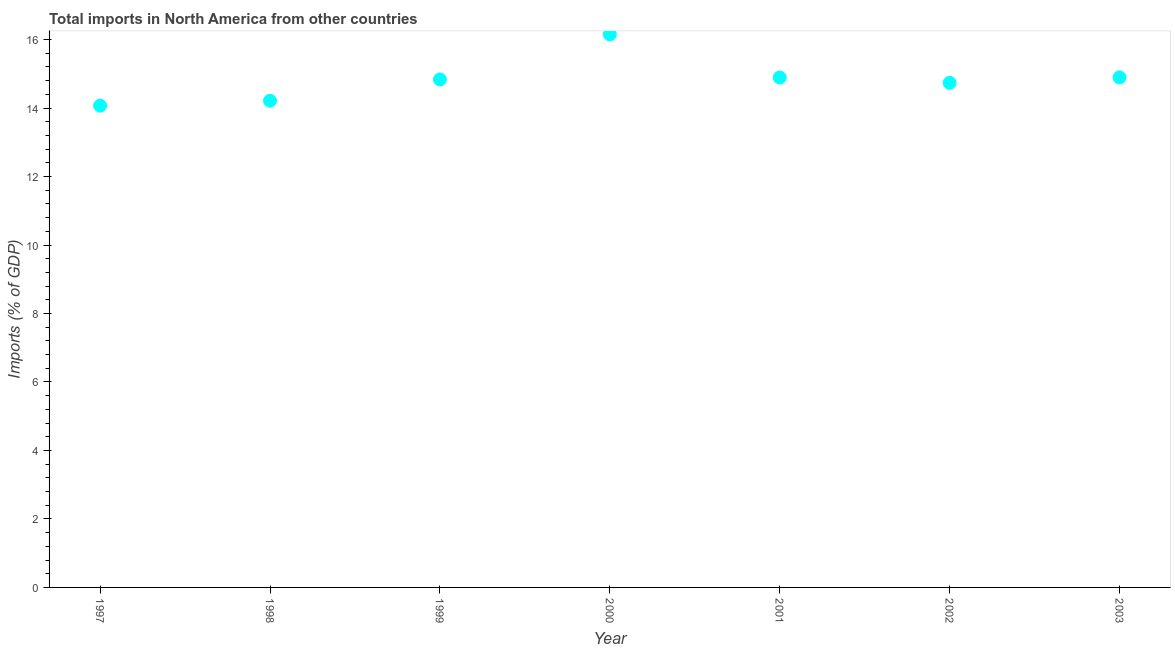What is the total imports in 1997?
Your answer should be very brief. 14.07. Across all years, what is the maximum total imports?
Your answer should be compact. 16.15. Across all years, what is the minimum total imports?
Offer a terse response. 14.07. In which year was the total imports minimum?
Provide a succinct answer. 1997. What is the sum of the total imports?
Offer a terse response. 103.8. What is the difference between the total imports in 2001 and 2003?
Provide a succinct answer. -0. What is the average total imports per year?
Offer a terse response. 14.83. What is the median total imports?
Offer a terse response. 14.84. What is the ratio of the total imports in 1998 to that in 2003?
Your answer should be compact. 0.95. Is the difference between the total imports in 2000 and 2002 greater than the difference between any two years?
Keep it short and to the point. No. What is the difference between the highest and the second highest total imports?
Provide a short and direct response. 1.26. Is the sum of the total imports in 1999 and 2003 greater than the maximum total imports across all years?
Offer a very short reply. Yes. What is the difference between the highest and the lowest total imports?
Give a very brief answer. 2.08. How many dotlines are there?
Offer a very short reply. 1. How many years are there in the graph?
Give a very brief answer. 7. Are the values on the major ticks of Y-axis written in scientific E-notation?
Make the answer very short. No. Does the graph contain any zero values?
Make the answer very short. No. What is the title of the graph?
Provide a succinct answer. Total imports in North America from other countries. What is the label or title of the X-axis?
Give a very brief answer. Year. What is the label or title of the Y-axis?
Ensure brevity in your answer.  Imports (% of GDP). What is the Imports (% of GDP) in 1997?
Your answer should be compact. 14.07. What is the Imports (% of GDP) in 1998?
Make the answer very short. 14.21. What is the Imports (% of GDP) in 1999?
Provide a succinct answer. 14.84. What is the Imports (% of GDP) in 2000?
Your answer should be compact. 16.15. What is the Imports (% of GDP) in 2001?
Your answer should be very brief. 14.89. What is the Imports (% of GDP) in 2002?
Offer a terse response. 14.74. What is the Imports (% of GDP) in 2003?
Offer a very short reply. 14.9. What is the difference between the Imports (% of GDP) in 1997 and 1998?
Provide a short and direct response. -0.14. What is the difference between the Imports (% of GDP) in 1997 and 1999?
Your answer should be very brief. -0.77. What is the difference between the Imports (% of GDP) in 1997 and 2000?
Ensure brevity in your answer.  -2.08. What is the difference between the Imports (% of GDP) in 1997 and 2001?
Make the answer very short. -0.82. What is the difference between the Imports (% of GDP) in 1997 and 2002?
Provide a succinct answer. -0.67. What is the difference between the Imports (% of GDP) in 1997 and 2003?
Keep it short and to the point. -0.83. What is the difference between the Imports (% of GDP) in 1998 and 1999?
Your answer should be very brief. -0.62. What is the difference between the Imports (% of GDP) in 1998 and 2000?
Provide a succinct answer. -1.94. What is the difference between the Imports (% of GDP) in 1998 and 2001?
Your answer should be compact. -0.68. What is the difference between the Imports (% of GDP) in 1998 and 2002?
Give a very brief answer. -0.52. What is the difference between the Imports (% of GDP) in 1998 and 2003?
Make the answer very short. -0.68. What is the difference between the Imports (% of GDP) in 1999 and 2000?
Provide a succinct answer. -1.32. What is the difference between the Imports (% of GDP) in 1999 and 2001?
Offer a very short reply. -0.06. What is the difference between the Imports (% of GDP) in 1999 and 2002?
Keep it short and to the point. 0.1. What is the difference between the Imports (% of GDP) in 1999 and 2003?
Ensure brevity in your answer.  -0.06. What is the difference between the Imports (% of GDP) in 2000 and 2001?
Keep it short and to the point. 1.26. What is the difference between the Imports (% of GDP) in 2000 and 2002?
Make the answer very short. 1.41. What is the difference between the Imports (% of GDP) in 2000 and 2003?
Offer a terse response. 1.26. What is the difference between the Imports (% of GDP) in 2001 and 2002?
Your answer should be compact. 0.16. What is the difference between the Imports (% of GDP) in 2001 and 2003?
Your answer should be compact. -0. What is the difference between the Imports (% of GDP) in 2002 and 2003?
Make the answer very short. -0.16. What is the ratio of the Imports (% of GDP) in 1997 to that in 1998?
Give a very brief answer. 0.99. What is the ratio of the Imports (% of GDP) in 1997 to that in 1999?
Keep it short and to the point. 0.95. What is the ratio of the Imports (% of GDP) in 1997 to that in 2000?
Provide a short and direct response. 0.87. What is the ratio of the Imports (% of GDP) in 1997 to that in 2001?
Offer a very short reply. 0.94. What is the ratio of the Imports (% of GDP) in 1997 to that in 2002?
Keep it short and to the point. 0.95. What is the ratio of the Imports (% of GDP) in 1997 to that in 2003?
Your answer should be compact. 0.94. What is the ratio of the Imports (% of GDP) in 1998 to that in 1999?
Ensure brevity in your answer.  0.96. What is the ratio of the Imports (% of GDP) in 1998 to that in 2000?
Ensure brevity in your answer.  0.88. What is the ratio of the Imports (% of GDP) in 1998 to that in 2001?
Your answer should be compact. 0.95. What is the ratio of the Imports (% of GDP) in 1998 to that in 2002?
Give a very brief answer. 0.96. What is the ratio of the Imports (% of GDP) in 1998 to that in 2003?
Offer a terse response. 0.95. What is the ratio of the Imports (% of GDP) in 1999 to that in 2000?
Make the answer very short. 0.92. What is the ratio of the Imports (% of GDP) in 1999 to that in 2002?
Give a very brief answer. 1.01. What is the ratio of the Imports (% of GDP) in 1999 to that in 2003?
Offer a terse response. 1. What is the ratio of the Imports (% of GDP) in 2000 to that in 2001?
Provide a succinct answer. 1.08. What is the ratio of the Imports (% of GDP) in 2000 to that in 2002?
Offer a terse response. 1.1. What is the ratio of the Imports (% of GDP) in 2000 to that in 2003?
Provide a succinct answer. 1.08. 